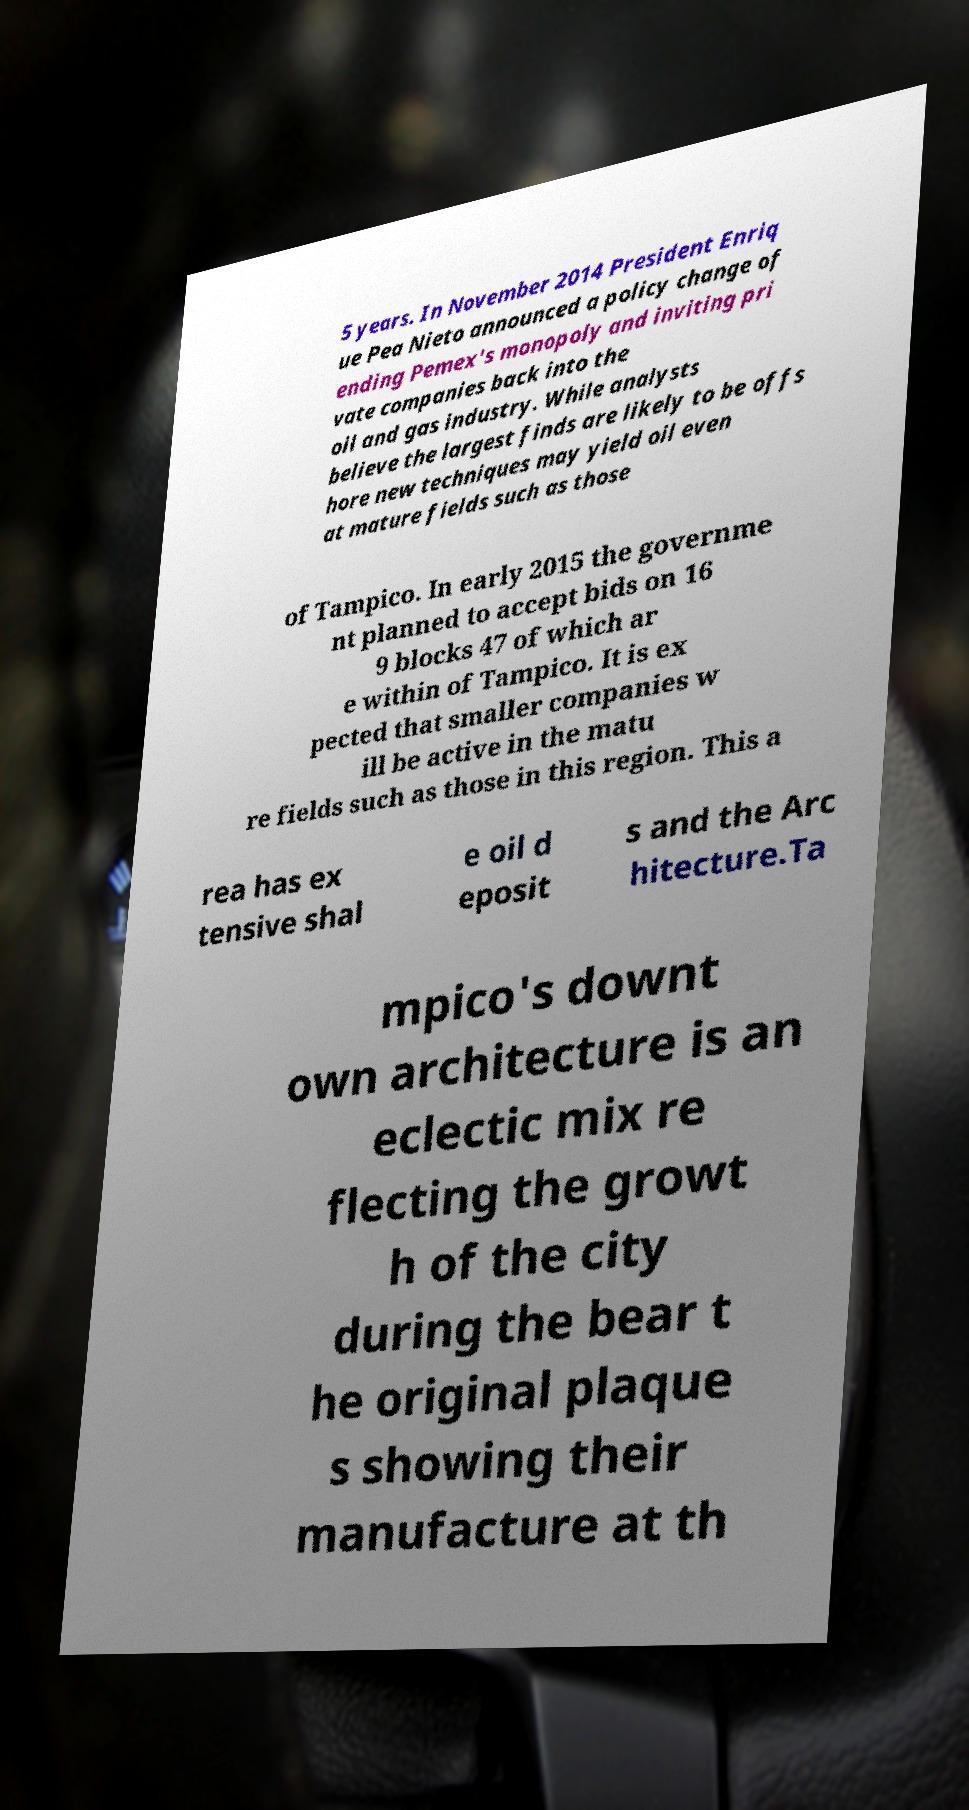Could you extract and type out the text from this image? 5 years. In November 2014 President Enriq ue Pea Nieto announced a policy change of ending Pemex's monopoly and inviting pri vate companies back into the oil and gas industry. While analysts believe the largest finds are likely to be offs hore new techniques may yield oil even at mature fields such as those of Tampico. In early 2015 the governme nt planned to accept bids on 16 9 blocks 47 of which ar e within of Tampico. It is ex pected that smaller companies w ill be active in the matu re fields such as those in this region. This a rea has ex tensive shal e oil d eposit s and the Arc hitecture.Ta mpico's downt own architecture is an eclectic mix re flecting the growt h of the city during the bear t he original plaque s showing their manufacture at th 